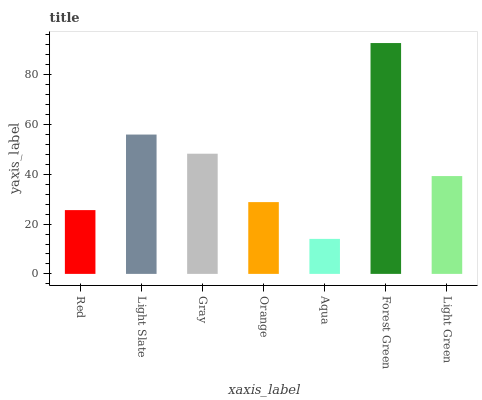Is Aqua the minimum?
Answer yes or no. Yes. Is Forest Green the maximum?
Answer yes or no. Yes. Is Light Slate the minimum?
Answer yes or no. No. Is Light Slate the maximum?
Answer yes or no. No. Is Light Slate greater than Red?
Answer yes or no. Yes. Is Red less than Light Slate?
Answer yes or no. Yes. Is Red greater than Light Slate?
Answer yes or no. No. Is Light Slate less than Red?
Answer yes or no. No. Is Light Green the high median?
Answer yes or no. Yes. Is Light Green the low median?
Answer yes or no. Yes. Is Forest Green the high median?
Answer yes or no. No. Is Light Slate the low median?
Answer yes or no. No. 